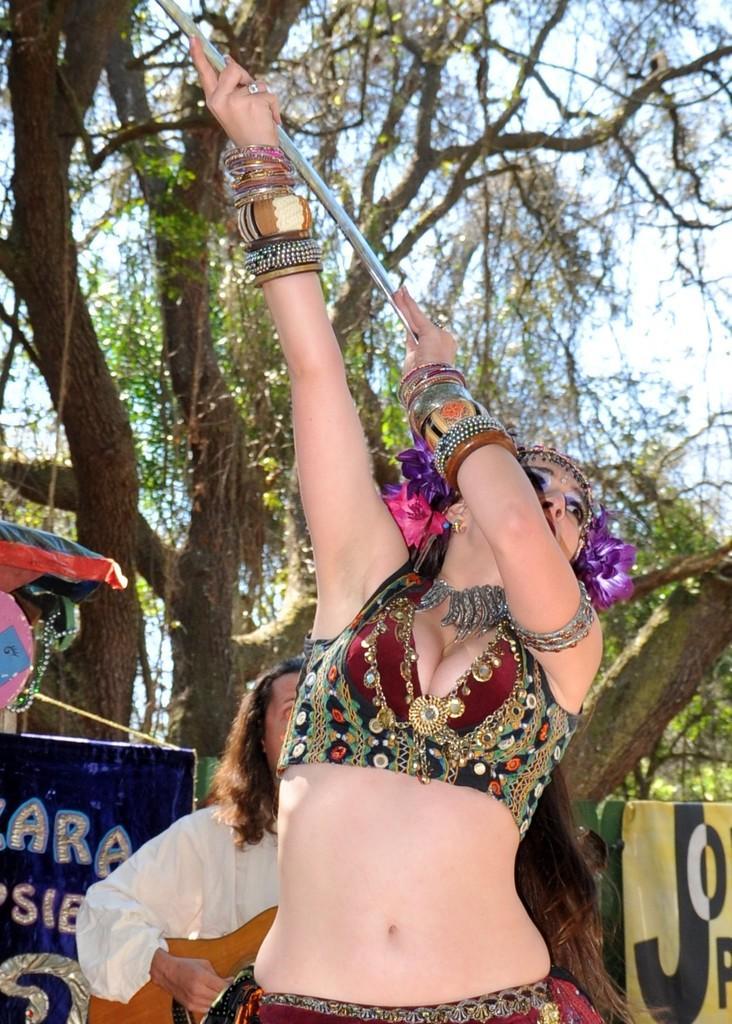Please provide a concise description of this image. In the foreground of this picture, there is a woman holding a rod and seems like she is dancing and in the background, there is a man with guitar, banners, trees and the sky. 